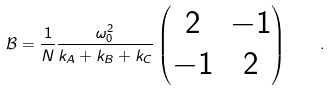<formula> <loc_0><loc_0><loc_500><loc_500>\mathcal { B } = \frac { 1 } { N } \frac { \omega _ { 0 } ^ { 2 } } { k _ { A } + k _ { B } + k _ { C } } \begin{pmatrix} 2 & - 1 \\ - 1 & 2 \end{pmatrix} \quad .</formula> 